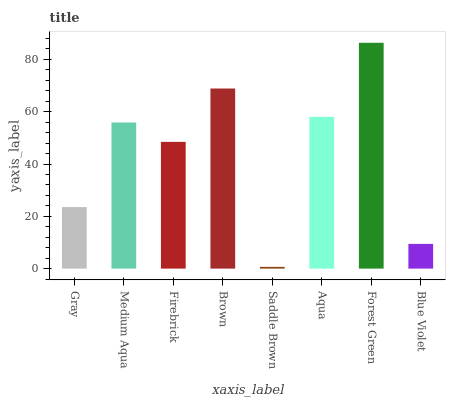Is Saddle Brown the minimum?
Answer yes or no. Yes. Is Forest Green the maximum?
Answer yes or no. Yes. Is Medium Aqua the minimum?
Answer yes or no. No. Is Medium Aqua the maximum?
Answer yes or no. No. Is Medium Aqua greater than Gray?
Answer yes or no. Yes. Is Gray less than Medium Aqua?
Answer yes or no. Yes. Is Gray greater than Medium Aqua?
Answer yes or no. No. Is Medium Aqua less than Gray?
Answer yes or no. No. Is Medium Aqua the high median?
Answer yes or no. Yes. Is Firebrick the low median?
Answer yes or no. Yes. Is Aqua the high median?
Answer yes or no. No. Is Saddle Brown the low median?
Answer yes or no. No. 